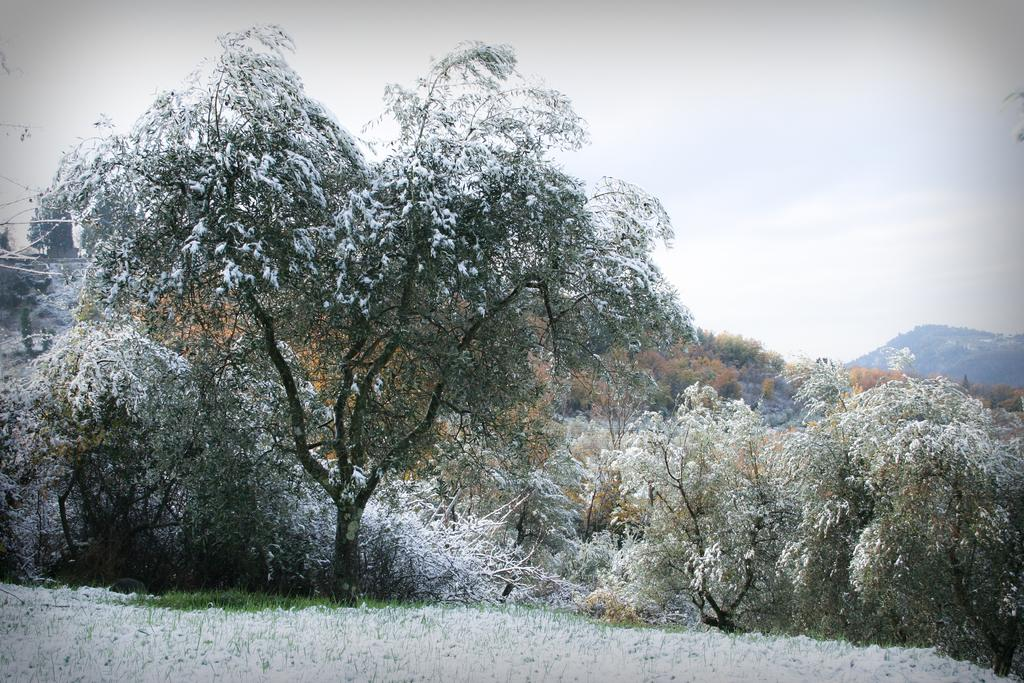What type of natural environment is depicted in the image? The image shows a group of trees with snow, indicating a winter landscape. What can be seen in the foreground of the image? There is grass visible in the foreground of the image. What is located on the right side of the image? There is a mountain on the right side of the image. What is visible at the top of the image? The sky is visible at the top of the image. What type of attraction can be seen in the image? There is no attraction present in the image; it depicts a natural winter landscape with trees, grass, a mountain, and the sky. Is there a turkey visible in the image? No, there is no turkey present in the image. 